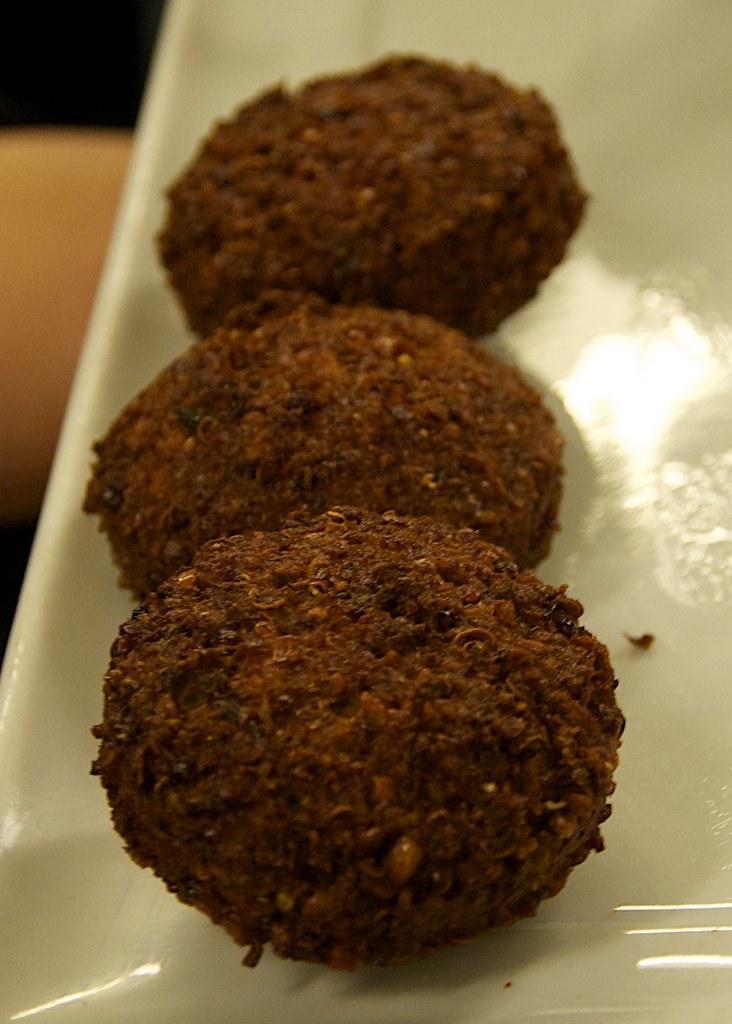Describe this image in one or two sentences. In this image, we can see some food items on a plate. We can see the ground and an object on the left. 